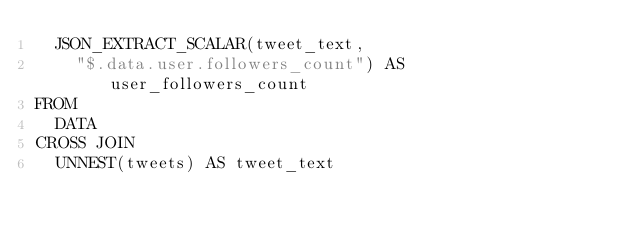Convert code to text. <code><loc_0><loc_0><loc_500><loc_500><_SQL_>  JSON_EXTRACT_SCALAR(tweet_text,
    "$.data.user.followers_count") AS user_followers_count
FROM
  DATA
CROSS JOIN
  UNNEST(tweets) AS tweet_text</code> 